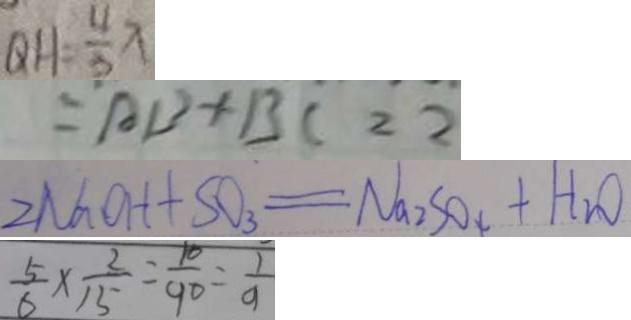<formula> <loc_0><loc_0><loc_500><loc_500>Q H = \frac { 4 } { 3 } x 
 = A B + B C = 2 
 2 N a O H + S O _ { 3 } = N a _ { 2 } S O _ { 4 } + H _ { 2 } O 
 \frac { 5 } { 6 } \times \frac { 2 } { 1 5 } = \frac { 1 0 } { 9 0 } = \frac { 1 } { 9 }</formula> 